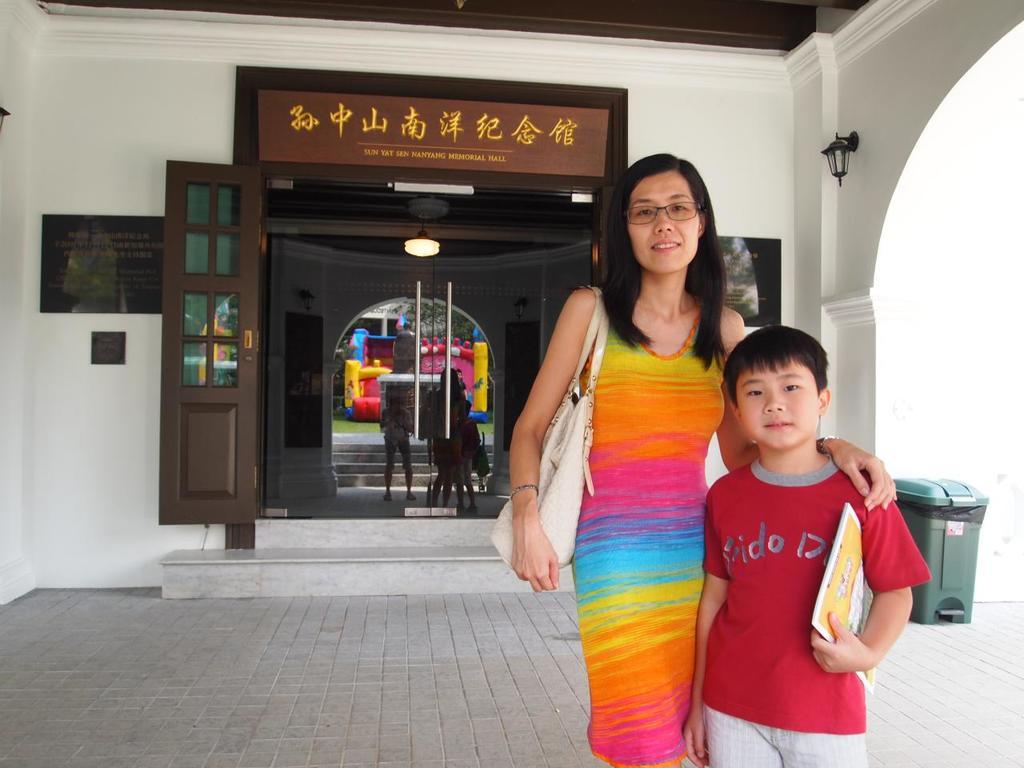What type of structure is in the image? There is a building in the image. What materials are used in the construction of the building? The building has boards and glass. What is located to the right of the building? There is a dustbin to the right of the building. What can be seen through the glass of the building? Lights, an inflatable object, and trees can be seen through the glass. What type of vegetable is growing on the building? There is no vegetable growing on the building in the image. --- Facts: 1. There is a car in the image. 2. The car is red. 3. The car has wheels. 4. The car is parked on the street. 5. There are people walking on the street. 6. There is a traffic light near the car. Absurd Topics: unicorn, rainbow, magic Conversation: What type of vehicle is in the image? There is a car in the image. What color is the car? The car is red. How many wheels does the car have? The car has wheels. Where is the car located in the image? The car is parked on the street. What else can be seen on the street in the image? There are people walking on the street. What is located near the car on the street? There is a traffic light near the car. Reasoning: Let's think step by step in order to produce the conversation. We start by identifying the main subject in the image, which is the car. Then, we describe specific features of the car, such as its color and the number of wheels it has. Next, we observe the car's location in the image, which is parked on the street. We then expand the conversation to include other elements visible on the street, such as people walking. Finally, we describe what is located near the car on the street, which is a traffic light. Absurd Question/Answer: What type of unicorn can be seen playing with the car in the image? There is no unicorn present in the image. --- Facts: 1. There is a dog in the image. 2. The dog is brown. 3. The dog is sitting. 4. The dog is sitting on a rug. 5. There is a fireplace near the dog. 6. There is a clock hanging above the fireplace. Absurd Topics: flying carpet, genie, magic lamp Conversation: What type of animal is in the image? There is a dog in the image. What color is the dog? The dog is brown. What position is the dog in? The dog is sitting. What is the dog sitting on in the image? The dog is sitting on a rug. What else can be seen near the dog in the image? There is a fire 